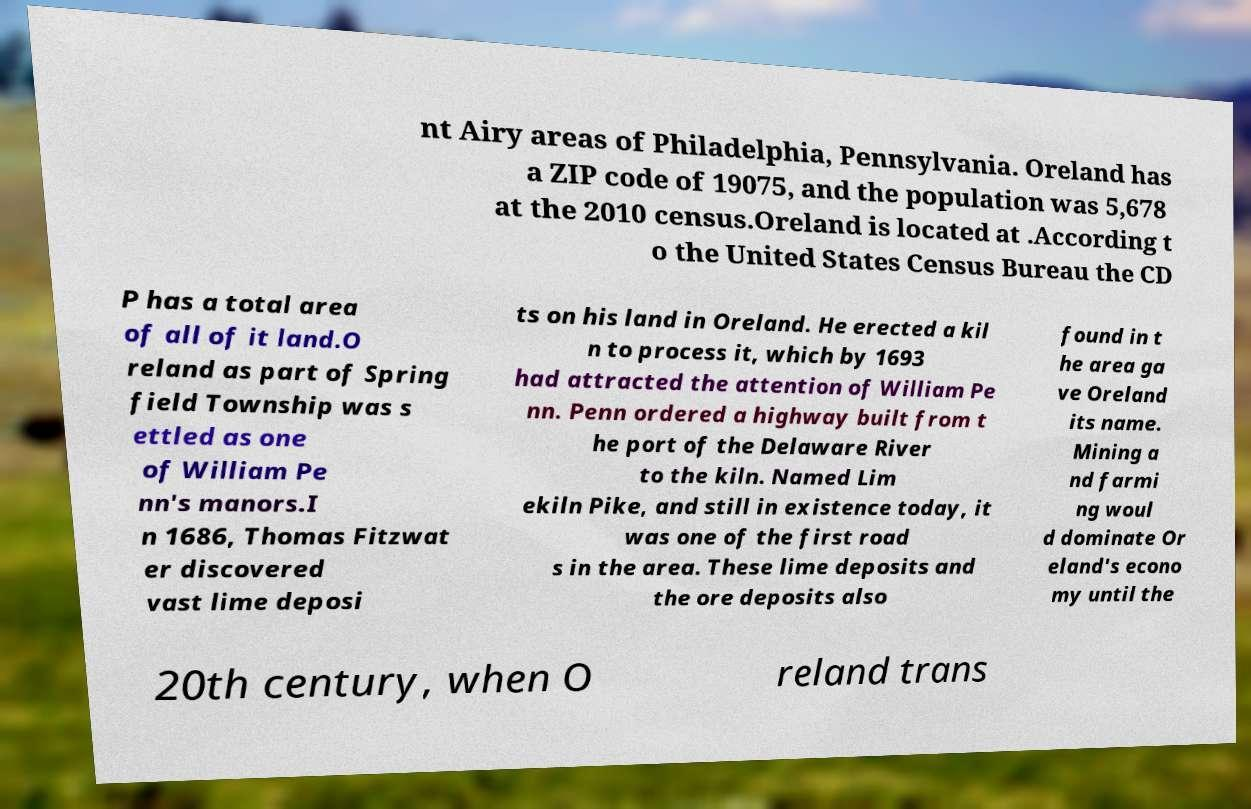Can you read and provide the text displayed in the image?This photo seems to have some interesting text. Can you extract and type it out for me? nt Airy areas of Philadelphia, Pennsylvania. Oreland has a ZIP code of 19075, and the population was 5,678 at the 2010 census.Oreland is located at .According t o the United States Census Bureau the CD P has a total area of all of it land.O reland as part of Spring field Township was s ettled as one of William Pe nn's manors.I n 1686, Thomas Fitzwat er discovered vast lime deposi ts on his land in Oreland. He erected a kil n to process it, which by 1693 had attracted the attention of William Pe nn. Penn ordered a highway built from t he port of the Delaware River to the kiln. Named Lim ekiln Pike, and still in existence today, it was one of the first road s in the area. These lime deposits and the ore deposits also found in t he area ga ve Oreland its name. Mining a nd farmi ng woul d dominate Or eland's econo my until the 20th century, when O reland trans 